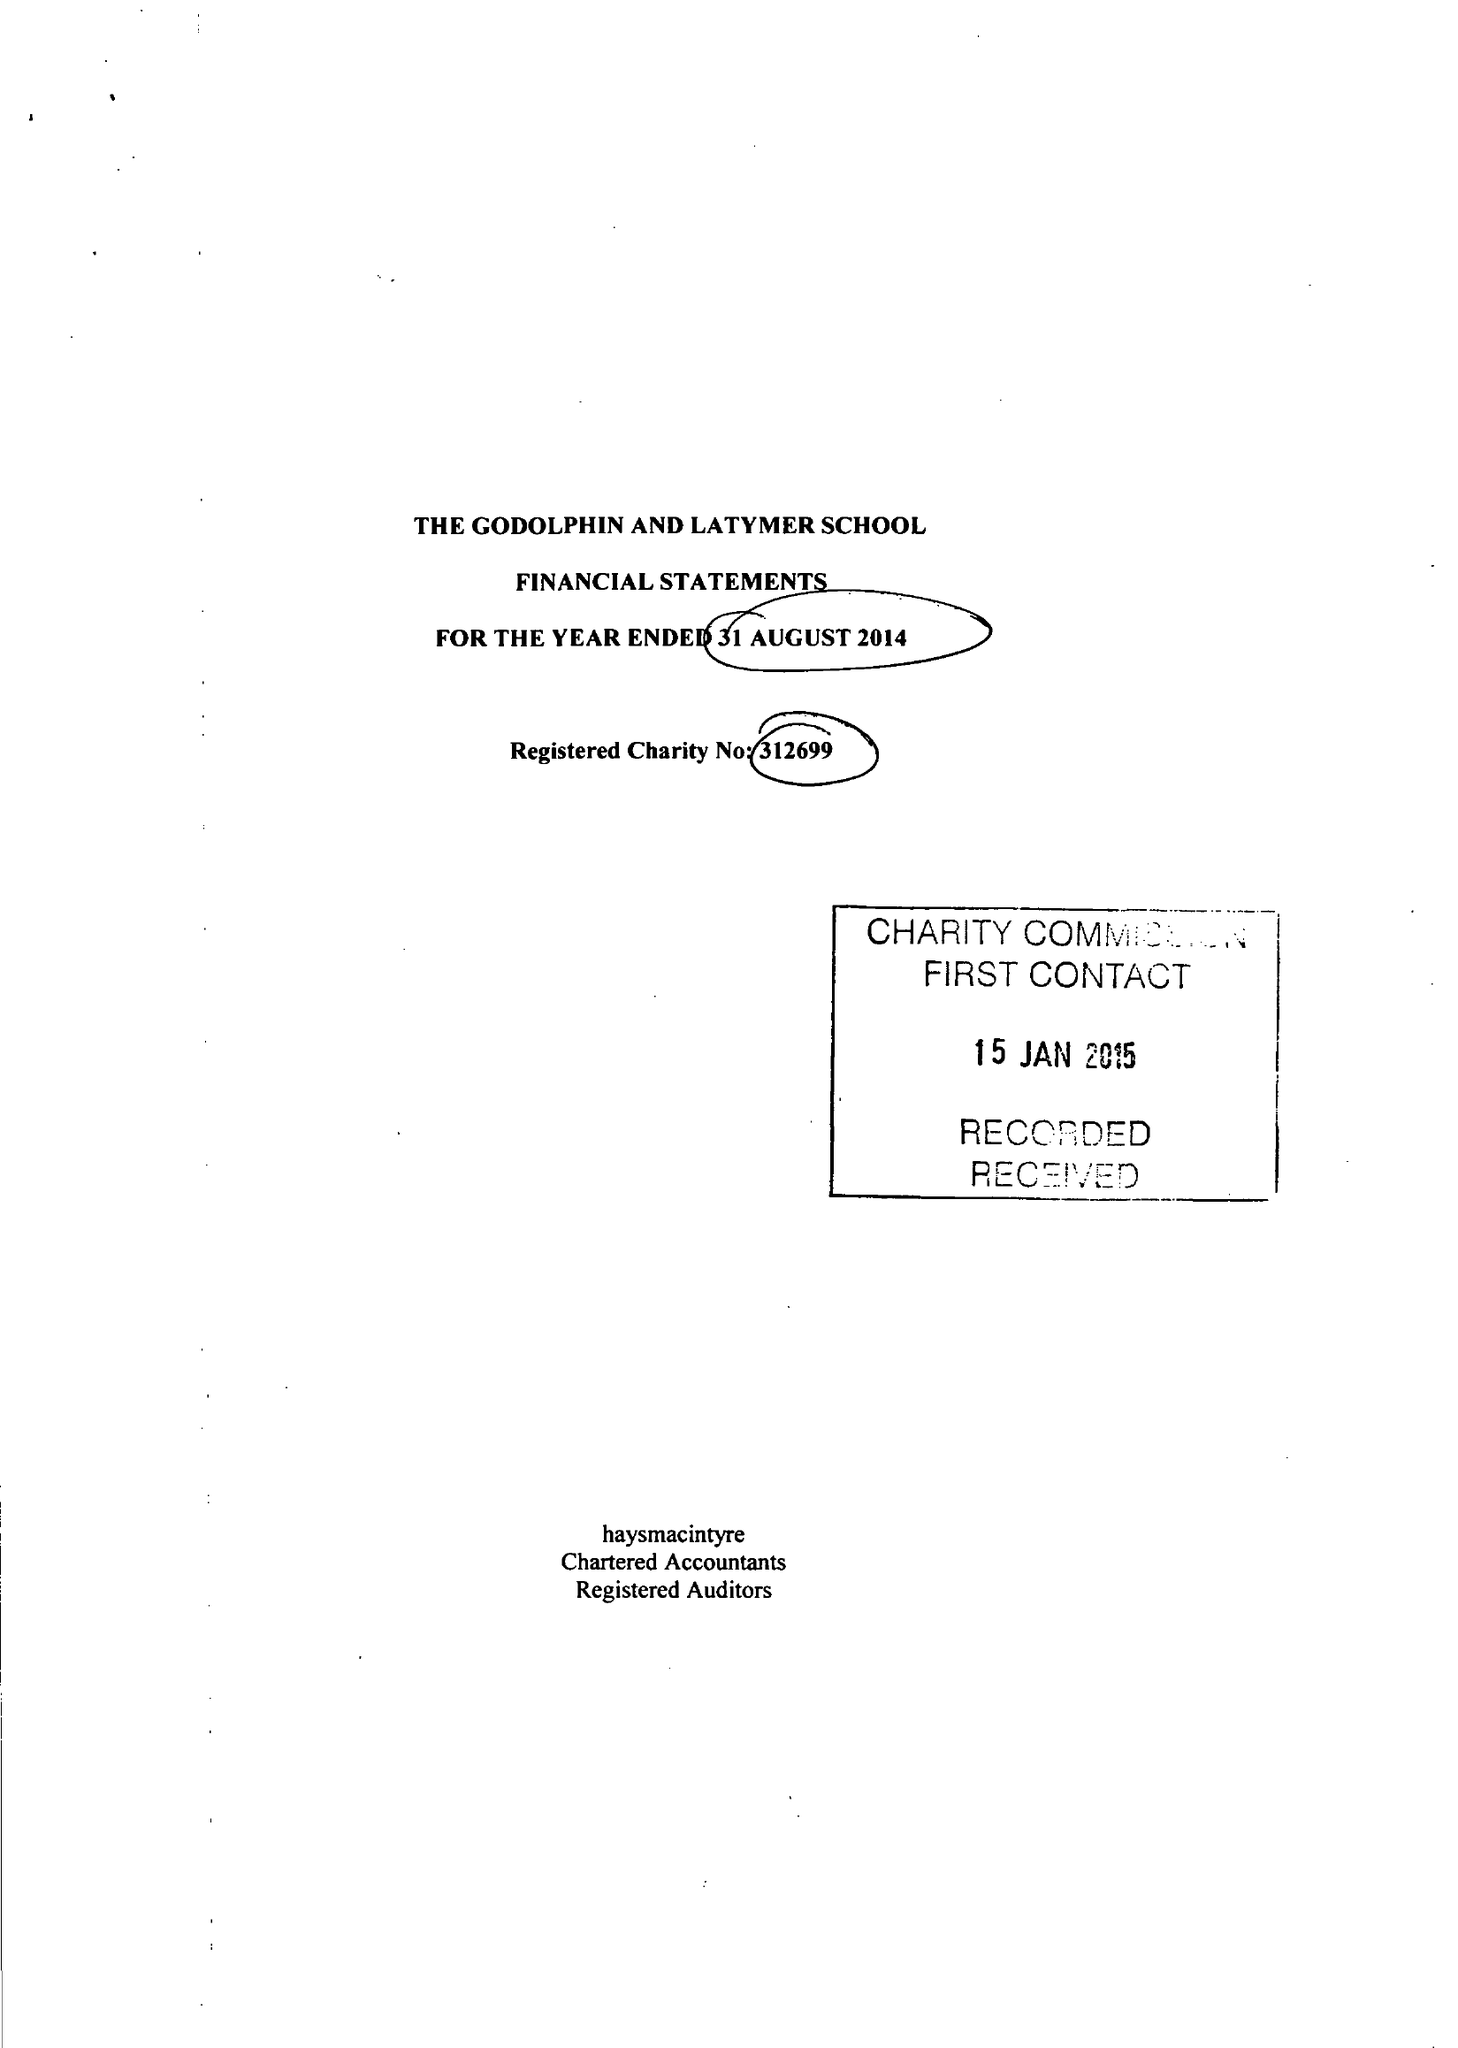What is the value for the address__postcode?
Answer the question using a single word or phrase. W6 0PG 